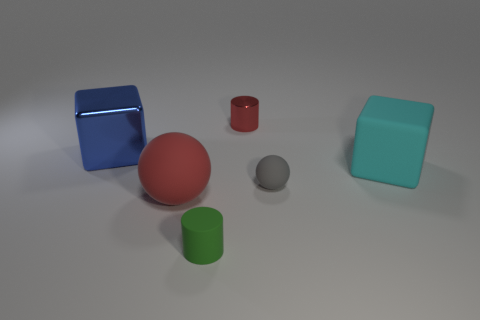What color is the small sphere?
Your answer should be very brief. Gray. Are there any brown things?
Your answer should be compact. No. Are there any large cyan blocks on the left side of the tiny red thing?
Offer a very short reply. No. There is a cyan object that is the same shape as the large blue object; what is its material?
Make the answer very short. Rubber. How many other things are there of the same shape as the big cyan thing?
Your answer should be very brief. 1. What number of tiny red objects are right of the large red matte object that is to the left of the large rubber object behind the red matte ball?
Make the answer very short. 1. How many large brown objects are the same shape as the big cyan object?
Ensure brevity in your answer.  0. There is a rubber sphere that is to the left of the small metal cylinder; does it have the same color as the small metallic thing?
Your answer should be very brief. Yes. There is a big rubber thing to the left of the tiny cylinder behind the large object to the right of the tiny green thing; what shape is it?
Your response must be concise. Sphere. There is a shiny cylinder; is its size the same as the red object in front of the cyan block?
Provide a short and direct response. No. 